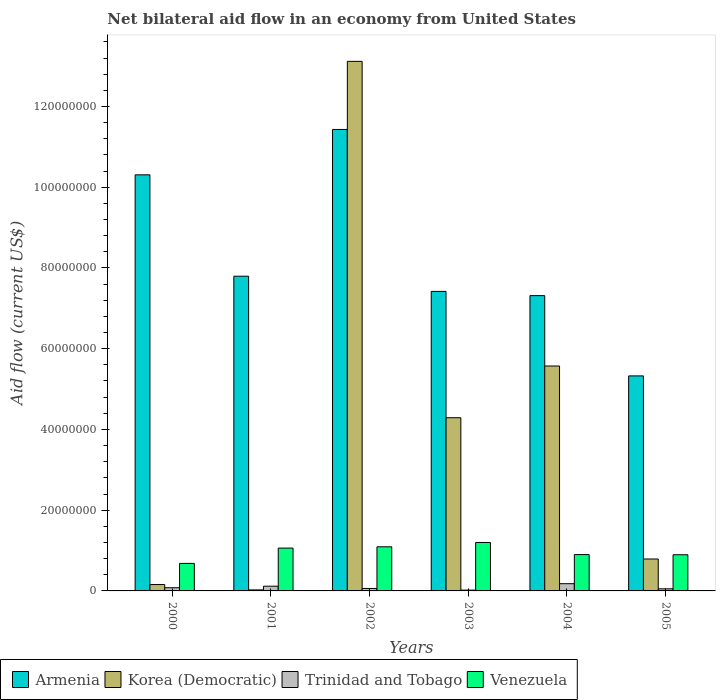Are the number of bars per tick equal to the number of legend labels?
Provide a short and direct response. Yes. Are the number of bars on each tick of the X-axis equal?
Make the answer very short. Yes. What is the label of the 6th group of bars from the left?
Ensure brevity in your answer.  2005. What is the net bilateral aid flow in Venezuela in 2001?
Offer a terse response. 1.06e+07. Across all years, what is the maximum net bilateral aid flow in Trinidad and Tobago?
Provide a short and direct response. 1.79e+06. Across all years, what is the minimum net bilateral aid flow in Trinidad and Tobago?
Offer a very short reply. 2.00e+05. What is the total net bilateral aid flow in Trinidad and Tobago in the graph?
Make the answer very short. 5.08e+06. What is the difference between the net bilateral aid flow in Venezuela in 2002 and that in 2003?
Give a very brief answer. -1.07e+06. What is the difference between the net bilateral aid flow in Venezuela in 2000 and the net bilateral aid flow in Trinidad and Tobago in 2005?
Make the answer very short. 6.30e+06. What is the average net bilateral aid flow in Korea (Democratic) per year?
Give a very brief answer. 3.99e+07. In the year 2000, what is the difference between the net bilateral aid flow in Armenia and net bilateral aid flow in Trinidad and Tobago?
Your answer should be compact. 1.02e+08. What is the ratio of the net bilateral aid flow in Venezuela in 2001 to that in 2004?
Provide a short and direct response. 1.18. What is the difference between the highest and the second highest net bilateral aid flow in Armenia?
Give a very brief answer. 1.12e+07. What is the difference between the highest and the lowest net bilateral aid flow in Venezuela?
Your answer should be very brief. 5.18e+06. Is it the case that in every year, the sum of the net bilateral aid flow in Armenia and net bilateral aid flow in Venezuela is greater than the sum of net bilateral aid flow in Korea (Democratic) and net bilateral aid flow in Trinidad and Tobago?
Your answer should be compact. Yes. What does the 1st bar from the left in 2002 represents?
Keep it short and to the point. Armenia. What does the 3rd bar from the right in 2002 represents?
Your response must be concise. Korea (Democratic). Is it the case that in every year, the sum of the net bilateral aid flow in Venezuela and net bilateral aid flow in Korea (Democratic) is greater than the net bilateral aid flow in Armenia?
Offer a terse response. No. How many bars are there?
Your answer should be very brief. 24. Are all the bars in the graph horizontal?
Keep it short and to the point. No. How many years are there in the graph?
Offer a very short reply. 6. Are the values on the major ticks of Y-axis written in scientific E-notation?
Your answer should be very brief. No. Does the graph contain grids?
Ensure brevity in your answer.  No. How many legend labels are there?
Provide a succinct answer. 4. What is the title of the graph?
Make the answer very short. Net bilateral aid flow in an economy from United States. Does "Rwanda" appear as one of the legend labels in the graph?
Give a very brief answer. No. What is the Aid flow (current US$) of Armenia in 2000?
Your response must be concise. 1.03e+08. What is the Aid flow (current US$) of Korea (Democratic) in 2000?
Ensure brevity in your answer.  1.58e+06. What is the Aid flow (current US$) of Trinidad and Tobago in 2000?
Keep it short and to the point. 7.90e+05. What is the Aid flow (current US$) in Venezuela in 2000?
Provide a short and direct response. 6.82e+06. What is the Aid flow (current US$) in Armenia in 2001?
Offer a very short reply. 7.80e+07. What is the Aid flow (current US$) of Korea (Democratic) in 2001?
Provide a short and direct response. 2.50e+05. What is the Aid flow (current US$) of Trinidad and Tobago in 2001?
Your answer should be very brief. 1.17e+06. What is the Aid flow (current US$) of Venezuela in 2001?
Your answer should be very brief. 1.06e+07. What is the Aid flow (current US$) in Armenia in 2002?
Provide a succinct answer. 1.14e+08. What is the Aid flow (current US$) in Korea (Democratic) in 2002?
Offer a very short reply. 1.31e+08. What is the Aid flow (current US$) in Trinidad and Tobago in 2002?
Provide a short and direct response. 6.10e+05. What is the Aid flow (current US$) of Venezuela in 2002?
Offer a terse response. 1.09e+07. What is the Aid flow (current US$) in Armenia in 2003?
Offer a very short reply. 7.42e+07. What is the Aid flow (current US$) of Korea (Democratic) in 2003?
Your response must be concise. 4.29e+07. What is the Aid flow (current US$) of Trinidad and Tobago in 2003?
Your answer should be compact. 2.00e+05. What is the Aid flow (current US$) of Venezuela in 2003?
Provide a short and direct response. 1.20e+07. What is the Aid flow (current US$) of Armenia in 2004?
Offer a very short reply. 7.31e+07. What is the Aid flow (current US$) of Korea (Democratic) in 2004?
Keep it short and to the point. 5.57e+07. What is the Aid flow (current US$) in Trinidad and Tobago in 2004?
Make the answer very short. 1.79e+06. What is the Aid flow (current US$) of Venezuela in 2004?
Ensure brevity in your answer.  9.00e+06. What is the Aid flow (current US$) of Armenia in 2005?
Provide a succinct answer. 5.33e+07. What is the Aid flow (current US$) of Korea (Democratic) in 2005?
Offer a very short reply. 7.91e+06. What is the Aid flow (current US$) of Trinidad and Tobago in 2005?
Provide a short and direct response. 5.20e+05. What is the Aid flow (current US$) in Venezuela in 2005?
Give a very brief answer. 8.96e+06. Across all years, what is the maximum Aid flow (current US$) of Armenia?
Give a very brief answer. 1.14e+08. Across all years, what is the maximum Aid flow (current US$) in Korea (Democratic)?
Offer a terse response. 1.31e+08. Across all years, what is the maximum Aid flow (current US$) in Trinidad and Tobago?
Offer a very short reply. 1.79e+06. Across all years, what is the maximum Aid flow (current US$) in Venezuela?
Offer a terse response. 1.20e+07. Across all years, what is the minimum Aid flow (current US$) in Armenia?
Provide a short and direct response. 5.33e+07. Across all years, what is the minimum Aid flow (current US$) in Korea (Democratic)?
Your answer should be very brief. 2.50e+05. Across all years, what is the minimum Aid flow (current US$) of Venezuela?
Your answer should be very brief. 6.82e+06. What is the total Aid flow (current US$) of Armenia in the graph?
Provide a succinct answer. 4.96e+08. What is the total Aid flow (current US$) in Korea (Democratic) in the graph?
Offer a terse response. 2.40e+08. What is the total Aid flow (current US$) in Trinidad and Tobago in the graph?
Your answer should be very brief. 5.08e+06. What is the total Aid flow (current US$) of Venezuela in the graph?
Keep it short and to the point. 5.83e+07. What is the difference between the Aid flow (current US$) in Armenia in 2000 and that in 2001?
Give a very brief answer. 2.51e+07. What is the difference between the Aid flow (current US$) in Korea (Democratic) in 2000 and that in 2001?
Your response must be concise. 1.33e+06. What is the difference between the Aid flow (current US$) in Trinidad and Tobago in 2000 and that in 2001?
Offer a very short reply. -3.80e+05. What is the difference between the Aid flow (current US$) of Venezuela in 2000 and that in 2001?
Give a very brief answer. -3.79e+06. What is the difference between the Aid flow (current US$) in Armenia in 2000 and that in 2002?
Make the answer very short. -1.12e+07. What is the difference between the Aid flow (current US$) of Korea (Democratic) in 2000 and that in 2002?
Your response must be concise. -1.30e+08. What is the difference between the Aid flow (current US$) in Trinidad and Tobago in 2000 and that in 2002?
Provide a succinct answer. 1.80e+05. What is the difference between the Aid flow (current US$) in Venezuela in 2000 and that in 2002?
Offer a terse response. -4.11e+06. What is the difference between the Aid flow (current US$) of Armenia in 2000 and that in 2003?
Your answer should be compact. 2.89e+07. What is the difference between the Aid flow (current US$) in Korea (Democratic) in 2000 and that in 2003?
Provide a succinct answer. -4.13e+07. What is the difference between the Aid flow (current US$) in Trinidad and Tobago in 2000 and that in 2003?
Your answer should be compact. 5.90e+05. What is the difference between the Aid flow (current US$) in Venezuela in 2000 and that in 2003?
Keep it short and to the point. -5.18e+06. What is the difference between the Aid flow (current US$) in Armenia in 2000 and that in 2004?
Keep it short and to the point. 2.99e+07. What is the difference between the Aid flow (current US$) in Korea (Democratic) in 2000 and that in 2004?
Offer a terse response. -5.41e+07. What is the difference between the Aid flow (current US$) in Trinidad and Tobago in 2000 and that in 2004?
Offer a very short reply. -1.00e+06. What is the difference between the Aid flow (current US$) of Venezuela in 2000 and that in 2004?
Your response must be concise. -2.18e+06. What is the difference between the Aid flow (current US$) in Armenia in 2000 and that in 2005?
Give a very brief answer. 4.98e+07. What is the difference between the Aid flow (current US$) in Korea (Democratic) in 2000 and that in 2005?
Provide a succinct answer. -6.33e+06. What is the difference between the Aid flow (current US$) in Trinidad and Tobago in 2000 and that in 2005?
Your response must be concise. 2.70e+05. What is the difference between the Aid flow (current US$) in Venezuela in 2000 and that in 2005?
Provide a short and direct response. -2.14e+06. What is the difference between the Aid flow (current US$) in Armenia in 2001 and that in 2002?
Your response must be concise. -3.64e+07. What is the difference between the Aid flow (current US$) of Korea (Democratic) in 2001 and that in 2002?
Offer a very short reply. -1.31e+08. What is the difference between the Aid flow (current US$) in Trinidad and Tobago in 2001 and that in 2002?
Your response must be concise. 5.60e+05. What is the difference between the Aid flow (current US$) in Venezuela in 2001 and that in 2002?
Keep it short and to the point. -3.20e+05. What is the difference between the Aid flow (current US$) in Armenia in 2001 and that in 2003?
Provide a short and direct response. 3.76e+06. What is the difference between the Aid flow (current US$) in Korea (Democratic) in 2001 and that in 2003?
Make the answer very short. -4.26e+07. What is the difference between the Aid flow (current US$) of Trinidad and Tobago in 2001 and that in 2003?
Offer a very short reply. 9.70e+05. What is the difference between the Aid flow (current US$) of Venezuela in 2001 and that in 2003?
Give a very brief answer. -1.39e+06. What is the difference between the Aid flow (current US$) of Armenia in 2001 and that in 2004?
Provide a short and direct response. 4.81e+06. What is the difference between the Aid flow (current US$) of Korea (Democratic) in 2001 and that in 2004?
Offer a terse response. -5.55e+07. What is the difference between the Aid flow (current US$) of Trinidad and Tobago in 2001 and that in 2004?
Provide a succinct answer. -6.20e+05. What is the difference between the Aid flow (current US$) of Venezuela in 2001 and that in 2004?
Keep it short and to the point. 1.61e+06. What is the difference between the Aid flow (current US$) of Armenia in 2001 and that in 2005?
Offer a terse response. 2.47e+07. What is the difference between the Aid flow (current US$) of Korea (Democratic) in 2001 and that in 2005?
Offer a very short reply. -7.66e+06. What is the difference between the Aid flow (current US$) in Trinidad and Tobago in 2001 and that in 2005?
Ensure brevity in your answer.  6.50e+05. What is the difference between the Aid flow (current US$) of Venezuela in 2001 and that in 2005?
Give a very brief answer. 1.65e+06. What is the difference between the Aid flow (current US$) of Armenia in 2002 and that in 2003?
Ensure brevity in your answer.  4.01e+07. What is the difference between the Aid flow (current US$) in Korea (Democratic) in 2002 and that in 2003?
Your answer should be very brief. 8.83e+07. What is the difference between the Aid flow (current US$) in Trinidad and Tobago in 2002 and that in 2003?
Provide a short and direct response. 4.10e+05. What is the difference between the Aid flow (current US$) in Venezuela in 2002 and that in 2003?
Keep it short and to the point. -1.07e+06. What is the difference between the Aid flow (current US$) of Armenia in 2002 and that in 2004?
Ensure brevity in your answer.  4.12e+07. What is the difference between the Aid flow (current US$) in Korea (Democratic) in 2002 and that in 2004?
Keep it short and to the point. 7.55e+07. What is the difference between the Aid flow (current US$) in Trinidad and Tobago in 2002 and that in 2004?
Keep it short and to the point. -1.18e+06. What is the difference between the Aid flow (current US$) of Venezuela in 2002 and that in 2004?
Give a very brief answer. 1.93e+06. What is the difference between the Aid flow (current US$) in Armenia in 2002 and that in 2005?
Make the answer very short. 6.10e+07. What is the difference between the Aid flow (current US$) of Korea (Democratic) in 2002 and that in 2005?
Your answer should be compact. 1.23e+08. What is the difference between the Aid flow (current US$) in Venezuela in 2002 and that in 2005?
Provide a succinct answer. 1.97e+06. What is the difference between the Aid flow (current US$) of Armenia in 2003 and that in 2004?
Your answer should be compact. 1.05e+06. What is the difference between the Aid flow (current US$) of Korea (Democratic) in 2003 and that in 2004?
Keep it short and to the point. -1.28e+07. What is the difference between the Aid flow (current US$) of Trinidad and Tobago in 2003 and that in 2004?
Provide a short and direct response. -1.59e+06. What is the difference between the Aid flow (current US$) of Venezuela in 2003 and that in 2004?
Keep it short and to the point. 3.00e+06. What is the difference between the Aid flow (current US$) of Armenia in 2003 and that in 2005?
Your response must be concise. 2.09e+07. What is the difference between the Aid flow (current US$) of Korea (Democratic) in 2003 and that in 2005?
Your answer should be very brief. 3.50e+07. What is the difference between the Aid flow (current US$) of Trinidad and Tobago in 2003 and that in 2005?
Keep it short and to the point. -3.20e+05. What is the difference between the Aid flow (current US$) of Venezuela in 2003 and that in 2005?
Your answer should be compact. 3.04e+06. What is the difference between the Aid flow (current US$) of Armenia in 2004 and that in 2005?
Provide a succinct answer. 1.99e+07. What is the difference between the Aid flow (current US$) in Korea (Democratic) in 2004 and that in 2005?
Offer a very short reply. 4.78e+07. What is the difference between the Aid flow (current US$) in Trinidad and Tobago in 2004 and that in 2005?
Keep it short and to the point. 1.27e+06. What is the difference between the Aid flow (current US$) in Armenia in 2000 and the Aid flow (current US$) in Korea (Democratic) in 2001?
Make the answer very short. 1.03e+08. What is the difference between the Aid flow (current US$) in Armenia in 2000 and the Aid flow (current US$) in Trinidad and Tobago in 2001?
Offer a very short reply. 1.02e+08. What is the difference between the Aid flow (current US$) in Armenia in 2000 and the Aid flow (current US$) in Venezuela in 2001?
Your response must be concise. 9.24e+07. What is the difference between the Aid flow (current US$) of Korea (Democratic) in 2000 and the Aid flow (current US$) of Venezuela in 2001?
Give a very brief answer. -9.03e+06. What is the difference between the Aid flow (current US$) in Trinidad and Tobago in 2000 and the Aid flow (current US$) in Venezuela in 2001?
Offer a very short reply. -9.82e+06. What is the difference between the Aid flow (current US$) of Armenia in 2000 and the Aid flow (current US$) of Korea (Democratic) in 2002?
Keep it short and to the point. -2.81e+07. What is the difference between the Aid flow (current US$) in Armenia in 2000 and the Aid flow (current US$) in Trinidad and Tobago in 2002?
Offer a very short reply. 1.02e+08. What is the difference between the Aid flow (current US$) in Armenia in 2000 and the Aid flow (current US$) in Venezuela in 2002?
Your response must be concise. 9.21e+07. What is the difference between the Aid flow (current US$) of Korea (Democratic) in 2000 and the Aid flow (current US$) of Trinidad and Tobago in 2002?
Give a very brief answer. 9.70e+05. What is the difference between the Aid flow (current US$) of Korea (Democratic) in 2000 and the Aid flow (current US$) of Venezuela in 2002?
Provide a short and direct response. -9.35e+06. What is the difference between the Aid flow (current US$) of Trinidad and Tobago in 2000 and the Aid flow (current US$) of Venezuela in 2002?
Provide a succinct answer. -1.01e+07. What is the difference between the Aid flow (current US$) in Armenia in 2000 and the Aid flow (current US$) in Korea (Democratic) in 2003?
Your answer should be very brief. 6.02e+07. What is the difference between the Aid flow (current US$) in Armenia in 2000 and the Aid flow (current US$) in Trinidad and Tobago in 2003?
Your answer should be very brief. 1.03e+08. What is the difference between the Aid flow (current US$) in Armenia in 2000 and the Aid flow (current US$) in Venezuela in 2003?
Provide a short and direct response. 9.11e+07. What is the difference between the Aid flow (current US$) of Korea (Democratic) in 2000 and the Aid flow (current US$) of Trinidad and Tobago in 2003?
Ensure brevity in your answer.  1.38e+06. What is the difference between the Aid flow (current US$) of Korea (Democratic) in 2000 and the Aid flow (current US$) of Venezuela in 2003?
Give a very brief answer. -1.04e+07. What is the difference between the Aid flow (current US$) of Trinidad and Tobago in 2000 and the Aid flow (current US$) of Venezuela in 2003?
Keep it short and to the point. -1.12e+07. What is the difference between the Aid flow (current US$) of Armenia in 2000 and the Aid flow (current US$) of Korea (Democratic) in 2004?
Provide a short and direct response. 4.74e+07. What is the difference between the Aid flow (current US$) of Armenia in 2000 and the Aid flow (current US$) of Trinidad and Tobago in 2004?
Make the answer very short. 1.01e+08. What is the difference between the Aid flow (current US$) in Armenia in 2000 and the Aid flow (current US$) in Venezuela in 2004?
Give a very brief answer. 9.41e+07. What is the difference between the Aid flow (current US$) in Korea (Democratic) in 2000 and the Aid flow (current US$) in Trinidad and Tobago in 2004?
Your answer should be very brief. -2.10e+05. What is the difference between the Aid flow (current US$) of Korea (Democratic) in 2000 and the Aid flow (current US$) of Venezuela in 2004?
Your response must be concise. -7.42e+06. What is the difference between the Aid flow (current US$) in Trinidad and Tobago in 2000 and the Aid flow (current US$) in Venezuela in 2004?
Provide a succinct answer. -8.21e+06. What is the difference between the Aid flow (current US$) in Armenia in 2000 and the Aid flow (current US$) in Korea (Democratic) in 2005?
Provide a short and direct response. 9.52e+07. What is the difference between the Aid flow (current US$) in Armenia in 2000 and the Aid flow (current US$) in Trinidad and Tobago in 2005?
Provide a succinct answer. 1.03e+08. What is the difference between the Aid flow (current US$) in Armenia in 2000 and the Aid flow (current US$) in Venezuela in 2005?
Offer a terse response. 9.41e+07. What is the difference between the Aid flow (current US$) in Korea (Democratic) in 2000 and the Aid flow (current US$) in Trinidad and Tobago in 2005?
Offer a very short reply. 1.06e+06. What is the difference between the Aid flow (current US$) in Korea (Democratic) in 2000 and the Aid flow (current US$) in Venezuela in 2005?
Provide a succinct answer. -7.38e+06. What is the difference between the Aid flow (current US$) in Trinidad and Tobago in 2000 and the Aid flow (current US$) in Venezuela in 2005?
Ensure brevity in your answer.  -8.17e+06. What is the difference between the Aid flow (current US$) in Armenia in 2001 and the Aid flow (current US$) in Korea (Democratic) in 2002?
Make the answer very short. -5.32e+07. What is the difference between the Aid flow (current US$) in Armenia in 2001 and the Aid flow (current US$) in Trinidad and Tobago in 2002?
Ensure brevity in your answer.  7.73e+07. What is the difference between the Aid flow (current US$) of Armenia in 2001 and the Aid flow (current US$) of Venezuela in 2002?
Your answer should be very brief. 6.70e+07. What is the difference between the Aid flow (current US$) of Korea (Democratic) in 2001 and the Aid flow (current US$) of Trinidad and Tobago in 2002?
Offer a terse response. -3.60e+05. What is the difference between the Aid flow (current US$) of Korea (Democratic) in 2001 and the Aid flow (current US$) of Venezuela in 2002?
Offer a very short reply. -1.07e+07. What is the difference between the Aid flow (current US$) of Trinidad and Tobago in 2001 and the Aid flow (current US$) of Venezuela in 2002?
Give a very brief answer. -9.76e+06. What is the difference between the Aid flow (current US$) of Armenia in 2001 and the Aid flow (current US$) of Korea (Democratic) in 2003?
Provide a succinct answer. 3.50e+07. What is the difference between the Aid flow (current US$) in Armenia in 2001 and the Aid flow (current US$) in Trinidad and Tobago in 2003?
Give a very brief answer. 7.78e+07. What is the difference between the Aid flow (current US$) in Armenia in 2001 and the Aid flow (current US$) in Venezuela in 2003?
Your answer should be very brief. 6.60e+07. What is the difference between the Aid flow (current US$) of Korea (Democratic) in 2001 and the Aid flow (current US$) of Venezuela in 2003?
Your answer should be compact. -1.18e+07. What is the difference between the Aid flow (current US$) in Trinidad and Tobago in 2001 and the Aid flow (current US$) in Venezuela in 2003?
Offer a terse response. -1.08e+07. What is the difference between the Aid flow (current US$) in Armenia in 2001 and the Aid flow (current US$) in Korea (Democratic) in 2004?
Offer a terse response. 2.22e+07. What is the difference between the Aid flow (current US$) of Armenia in 2001 and the Aid flow (current US$) of Trinidad and Tobago in 2004?
Give a very brief answer. 7.62e+07. What is the difference between the Aid flow (current US$) in Armenia in 2001 and the Aid flow (current US$) in Venezuela in 2004?
Keep it short and to the point. 6.90e+07. What is the difference between the Aid flow (current US$) of Korea (Democratic) in 2001 and the Aid flow (current US$) of Trinidad and Tobago in 2004?
Provide a succinct answer. -1.54e+06. What is the difference between the Aid flow (current US$) of Korea (Democratic) in 2001 and the Aid flow (current US$) of Venezuela in 2004?
Keep it short and to the point. -8.75e+06. What is the difference between the Aid flow (current US$) of Trinidad and Tobago in 2001 and the Aid flow (current US$) of Venezuela in 2004?
Offer a terse response. -7.83e+06. What is the difference between the Aid flow (current US$) of Armenia in 2001 and the Aid flow (current US$) of Korea (Democratic) in 2005?
Offer a very short reply. 7.00e+07. What is the difference between the Aid flow (current US$) of Armenia in 2001 and the Aid flow (current US$) of Trinidad and Tobago in 2005?
Offer a terse response. 7.74e+07. What is the difference between the Aid flow (current US$) in Armenia in 2001 and the Aid flow (current US$) in Venezuela in 2005?
Ensure brevity in your answer.  6.90e+07. What is the difference between the Aid flow (current US$) in Korea (Democratic) in 2001 and the Aid flow (current US$) in Trinidad and Tobago in 2005?
Your answer should be very brief. -2.70e+05. What is the difference between the Aid flow (current US$) in Korea (Democratic) in 2001 and the Aid flow (current US$) in Venezuela in 2005?
Your answer should be very brief. -8.71e+06. What is the difference between the Aid flow (current US$) in Trinidad and Tobago in 2001 and the Aid flow (current US$) in Venezuela in 2005?
Provide a short and direct response. -7.79e+06. What is the difference between the Aid flow (current US$) in Armenia in 2002 and the Aid flow (current US$) in Korea (Democratic) in 2003?
Your answer should be compact. 7.14e+07. What is the difference between the Aid flow (current US$) in Armenia in 2002 and the Aid flow (current US$) in Trinidad and Tobago in 2003?
Offer a very short reply. 1.14e+08. What is the difference between the Aid flow (current US$) in Armenia in 2002 and the Aid flow (current US$) in Venezuela in 2003?
Offer a terse response. 1.02e+08. What is the difference between the Aid flow (current US$) in Korea (Democratic) in 2002 and the Aid flow (current US$) in Trinidad and Tobago in 2003?
Offer a very short reply. 1.31e+08. What is the difference between the Aid flow (current US$) of Korea (Democratic) in 2002 and the Aid flow (current US$) of Venezuela in 2003?
Make the answer very short. 1.19e+08. What is the difference between the Aid flow (current US$) of Trinidad and Tobago in 2002 and the Aid flow (current US$) of Venezuela in 2003?
Give a very brief answer. -1.14e+07. What is the difference between the Aid flow (current US$) in Armenia in 2002 and the Aid flow (current US$) in Korea (Democratic) in 2004?
Offer a terse response. 5.86e+07. What is the difference between the Aid flow (current US$) of Armenia in 2002 and the Aid flow (current US$) of Trinidad and Tobago in 2004?
Your answer should be compact. 1.13e+08. What is the difference between the Aid flow (current US$) in Armenia in 2002 and the Aid flow (current US$) in Venezuela in 2004?
Your answer should be very brief. 1.05e+08. What is the difference between the Aid flow (current US$) in Korea (Democratic) in 2002 and the Aid flow (current US$) in Trinidad and Tobago in 2004?
Ensure brevity in your answer.  1.29e+08. What is the difference between the Aid flow (current US$) of Korea (Democratic) in 2002 and the Aid flow (current US$) of Venezuela in 2004?
Provide a short and direct response. 1.22e+08. What is the difference between the Aid flow (current US$) in Trinidad and Tobago in 2002 and the Aid flow (current US$) in Venezuela in 2004?
Offer a terse response. -8.39e+06. What is the difference between the Aid flow (current US$) in Armenia in 2002 and the Aid flow (current US$) in Korea (Democratic) in 2005?
Provide a short and direct response. 1.06e+08. What is the difference between the Aid flow (current US$) in Armenia in 2002 and the Aid flow (current US$) in Trinidad and Tobago in 2005?
Give a very brief answer. 1.14e+08. What is the difference between the Aid flow (current US$) of Armenia in 2002 and the Aid flow (current US$) of Venezuela in 2005?
Keep it short and to the point. 1.05e+08. What is the difference between the Aid flow (current US$) of Korea (Democratic) in 2002 and the Aid flow (current US$) of Trinidad and Tobago in 2005?
Offer a very short reply. 1.31e+08. What is the difference between the Aid flow (current US$) in Korea (Democratic) in 2002 and the Aid flow (current US$) in Venezuela in 2005?
Provide a short and direct response. 1.22e+08. What is the difference between the Aid flow (current US$) in Trinidad and Tobago in 2002 and the Aid flow (current US$) in Venezuela in 2005?
Your response must be concise. -8.35e+06. What is the difference between the Aid flow (current US$) in Armenia in 2003 and the Aid flow (current US$) in Korea (Democratic) in 2004?
Keep it short and to the point. 1.85e+07. What is the difference between the Aid flow (current US$) in Armenia in 2003 and the Aid flow (current US$) in Trinidad and Tobago in 2004?
Your response must be concise. 7.24e+07. What is the difference between the Aid flow (current US$) in Armenia in 2003 and the Aid flow (current US$) in Venezuela in 2004?
Offer a very short reply. 6.52e+07. What is the difference between the Aid flow (current US$) of Korea (Democratic) in 2003 and the Aid flow (current US$) of Trinidad and Tobago in 2004?
Offer a terse response. 4.11e+07. What is the difference between the Aid flow (current US$) in Korea (Democratic) in 2003 and the Aid flow (current US$) in Venezuela in 2004?
Provide a short and direct response. 3.39e+07. What is the difference between the Aid flow (current US$) in Trinidad and Tobago in 2003 and the Aid flow (current US$) in Venezuela in 2004?
Offer a very short reply. -8.80e+06. What is the difference between the Aid flow (current US$) in Armenia in 2003 and the Aid flow (current US$) in Korea (Democratic) in 2005?
Offer a terse response. 6.63e+07. What is the difference between the Aid flow (current US$) of Armenia in 2003 and the Aid flow (current US$) of Trinidad and Tobago in 2005?
Provide a short and direct response. 7.37e+07. What is the difference between the Aid flow (current US$) of Armenia in 2003 and the Aid flow (current US$) of Venezuela in 2005?
Offer a very short reply. 6.52e+07. What is the difference between the Aid flow (current US$) of Korea (Democratic) in 2003 and the Aid flow (current US$) of Trinidad and Tobago in 2005?
Provide a succinct answer. 4.24e+07. What is the difference between the Aid flow (current US$) in Korea (Democratic) in 2003 and the Aid flow (current US$) in Venezuela in 2005?
Ensure brevity in your answer.  3.39e+07. What is the difference between the Aid flow (current US$) in Trinidad and Tobago in 2003 and the Aid flow (current US$) in Venezuela in 2005?
Make the answer very short. -8.76e+06. What is the difference between the Aid flow (current US$) in Armenia in 2004 and the Aid flow (current US$) in Korea (Democratic) in 2005?
Your response must be concise. 6.52e+07. What is the difference between the Aid flow (current US$) in Armenia in 2004 and the Aid flow (current US$) in Trinidad and Tobago in 2005?
Provide a short and direct response. 7.26e+07. What is the difference between the Aid flow (current US$) of Armenia in 2004 and the Aid flow (current US$) of Venezuela in 2005?
Offer a terse response. 6.42e+07. What is the difference between the Aid flow (current US$) of Korea (Democratic) in 2004 and the Aid flow (current US$) of Trinidad and Tobago in 2005?
Keep it short and to the point. 5.52e+07. What is the difference between the Aid flow (current US$) in Korea (Democratic) in 2004 and the Aid flow (current US$) in Venezuela in 2005?
Provide a succinct answer. 4.68e+07. What is the difference between the Aid flow (current US$) of Trinidad and Tobago in 2004 and the Aid flow (current US$) of Venezuela in 2005?
Provide a succinct answer. -7.17e+06. What is the average Aid flow (current US$) in Armenia per year?
Give a very brief answer. 8.26e+07. What is the average Aid flow (current US$) in Korea (Democratic) per year?
Keep it short and to the point. 3.99e+07. What is the average Aid flow (current US$) in Trinidad and Tobago per year?
Your response must be concise. 8.47e+05. What is the average Aid flow (current US$) of Venezuela per year?
Make the answer very short. 9.72e+06. In the year 2000, what is the difference between the Aid flow (current US$) in Armenia and Aid flow (current US$) in Korea (Democratic)?
Give a very brief answer. 1.01e+08. In the year 2000, what is the difference between the Aid flow (current US$) in Armenia and Aid flow (current US$) in Trinidad and Tobago?
Keep it short and to the point. 1.02e+08. In the year 2000, what is the difference between the Aid flow (current US$) in Armenia and Aid flow (current US$) in Venezuela?
Your answer should be very brief. 9.62e+07. In the year 2000, what is the difference between the Aid flow (current US$) in Korea (Democratic) and Aid flow (current US$) in Trinidad and Tobago?
Your answer should be compact. 7.90e+05. In the year 2000, what is the difference between the Aid flow (current US$) of Korea (Democratic) and Aid flow (current US$) of Venezuela?
Your answer should be compact. -5.24e+06. In the year 2000, what is the difference between the Aid flow (current US$) of Trinidad and Tobago and Aid flow (current US$) of Venezuela?
Keep it short and to the point. -6.03e+06. In the year 2001, what is the difference between the Aid flow (current US$) of Armenia and Aid flow (current US$) of Korea (Democratic)?
Provide a succinct answer. 7.77e+07. In the year 2001, what is the difference between the Aid flow (current US$) in Armenia and Aid flow (current US$) in Trinidad and Tobago?
Offer a very short reply. 7.68e+07. In the year 2001, what is the difference between the Aid flow (current US$) in Armenia and Aid flow (current US$) in Venezuela?
Your response must be concise. 6.73e+07. In the year 2001, what is the difference between the Aid flow (current US$) of Korea (Democratic) and Aid flow (current US$) of Trinidad and Tobago?
Give a very brief answer. -9.20e+05. In the year 2001, what is the difference between the Aid flow (current US$) of Korea (Democratic) and Aid flow (current US$) of Venezuela?
Your response must be concise. -1.04e+07. In the year 2001, what is the difference between the Aid flow (current US$) in Trinidad and Tobago and Aid flow (current US$) in Venezuela?
Make the answer very short. -9.44e+06. In the year 2002, what is the difference between the Aid flow (current US$) in Armenia and Aid flow (current US$) in Korea (Democratic)?
Your response must be concise. -1.69e+07. In the year 2002, what is the difference between the Aid flow (current US$) of Armenia and Aid flow (current US$) of Trinidad and Tobago?
Provide a succinct answer. 1.14e+08. In the year 2002, what is the difference between the Aid flow (current US$) of Armenia and Aid flow (current US$) of Venezuela?
Make the answer very short. 1.03e+08. In the year 2002, what is the difference between the Aid flow (current US$) of Korea (Democratic) and Aid flow (current US$) of Trinidad and Tobago?
Offer a very short reply. 1.31e+08. In the year 2002, what is the difference between the Aid flow (current US$) in Korea (Democratic) and Aid flow (current US$) in Venezuela?
Keep it short and to the point. 1.20e+08. In the year 2002, what is the difference between the Aid flow (current US$) in Trinidad and Tobago and Aid flow (current US$) in Venezuela?
Your answer should be very brief. -1.03e+07. In the year 2003, what is the difference between the Aid flow (current US$) in Armenia and Aid flow (current US$) in Korea (Democratic)?
Offer a terse response. 3.13e+07. In the year 2003, what is the difference between the Aid flow (current US$) in Armenia and Aid flow (current US$) in Trinidad and Tobago?
Provide a short and direct response. 7.40e+07. In the year 2003, what is the difference between the Aid flow (current US$) of Armenia and Aid flow (current US$) of Venezuela?
Your answer should be compact. 6.22e+07. In the year 2003, what is the difference between the Aid flow (current US$) of Korea (Democratic) and Aid flow (current US$) of Trinidad and Tobago?
Offer a very short reply. 4.27e+07. In the year 2003, what is the difference between the Aid flow (current US$) in Korea (Democratic) and Aid flow (current US$) in Venezuela?
Give a very brief answer. 3.09e+07. In the year 2003, what is the difference between the Aid flow (current US$) in Trinidad and Tobago and Aid flow (current US$) in Venezuela?
Provide a short and direct response. -1.18e+07. In the year 2004, what is the difference between the Aid flow (current US$) in Armenia and Aid flow (current US$) in Korea (Democratic)?
Offer a terse response. 1.74e+07. In the year 2004, what is the difference between the Aid flow (current US$) of Armenia and Aid flow (current US$) of Trinidad and Tobago?
Your answer should be compact. 7.14e+07. In the year 2004, what is the difference between the Aid flow (current US$) of Armenia and Aid flow (current US$) of Venezuela?
Your answer should be very brief. 6.41e+07. In the year 2004, what is the difference between the Aid flow (current US$) in Korea (Democratic) and Aid flow (current US$) in Trinidad and Tobago?
Your response must be concise. 5.39e+07. In the year 2004, what is the difference between the Aid flow (current US$) in Korea (Democratic) and Aid flow (current US$) in Venezuela?
Provide a short and direct response. 4.67e+07. In the year 2004, what is the difference between the Aid flow (current US$) of Trinidad and Tobago and Aid flow (current US$) of Venezuela?
Offer a very short reply. -7.21e+06. In the year 2005, what is the difference between the Aid flow (current US$) of Armenia and Aid flow (current US$) of Korea (Democratic)?
Make the answer very short. 4.54e+07. In the year 2005, what is the difference between the Aid flow (current US$) in Armenia and Aid flow (current US$) in Trinidad and Tobago?
Your answer should be compact. 5.27e+07. In the year 2005, what is the difference between the Aid flow (current US$) of Armenia and Aid flow (current US$) of Venezuela?
Make the answer very short. 4.43e+07. In the year 2005, what is the difference between the Aid flow (current US$) of Korea (Democratic) and Aid flow (current US$) of Trinidad and Tobago?
Your response must be concise. 7.39e+06. In the year 2005, what is the difference between the Aid flow (current US$) in Korea (Democratic) and Aid flow (current US$) in Venezuela?
Give a very brief answer. -1.05e+06. In the year 2005, what is the difference between the Aid flow (current US$) of Trinidad and Tobago and Aid flow (current US$) of Venezuela?
Make the answer very short. -8.44e+06. What is the ratio of the Aid flow (current US$) of Armenia in 2000 to that in 2001?
Your answer should be compact. 1.32. What is the ratio of the Aid flow (current US$) in Korea (Democratic) in 2000 to that in 2001?
Keep it short and to the point. 6.32. What is the ratio of the Aid flow (current US$) of Trinidad and Tobago in 2000 to that in 2001?
Your response must be concise. 0.68. What is the ratio of the Aid flow (current US$) of Venezuela in 2000 to that in 2001?
Ensure brevity in your answer.  0.64. What is the ratio of the Aid flow (current US$) of Armenia in 2000 to that in 2002?
Your answer should be very brief. 0.9. What is the ratio of the Aid flow (current US$) in Korea (Democratic) in 2000 to that in 2002?
Give a very brief answer. 0.01. What is the ratio of the Aid flow (current US$) of Trinidad and Tobago in 2000 to that in 2002?
Make the answer very short. 1.3. What is the ratio of the Aid flow (current US$) of Venezuela in 2000 to that in 2002?
Ensure brevity in your answer.  0.62. What is the ratio of the Aid flow (current US$) in Armenia in 2000 to that in 2003?
Ensure brevity in your answer.  1.39. What is the ratio of the Aid flow (current US$) in Korea (Democratic) in 2000 to that in 2003?
Offer a terse response. 0.04. What is the ratio of the Aid flow (current US$) of Trinidad and Tobago in 2000 to that in 2003?
Ensure brevity in your answer.  3.95. What is the ratio of the Aid flow (current US$) in Venezuela in 2000 to that in 2003?
Keep it short and to the point. 0.57. What is the ratio of the Aid flow (current US$) of Armenia in 2000 to that in 2004?
Your response must be concise. 1.41. What is the ratio of the Aid flow (current US$) of Korea (Democratic) in 2000 to that in 2004?
Provide a short and direct response. 0.03. What is the ratio of the Aid flow (current US$) of Trinidad and Tobago in 2000 to that in 2004?
Offer a terse response. 0.44. What is the ratio of the Aid flow (current US$) of Venezuela in 2000 to that in 2004?
Keep it short and to the point. 0.76. What is the ratio of the Aid flow (current US$) of Armenia in 2000 to that in 2005?
Ensure brevity in your answer.  1.94. What is the ratio of the Aid flow (current US$) in Korea (Democratic) in 2000 to that in 2005?
Offer a terse response. 0.2. What is the ratio of the Aid flow (current US$) in Trinidad and Tobago in 2000 to that in 2005?
Make the answer very short. 1.52. What is the ratio of the Aid flow (current US$) in Venezuela in 2000 to that in 2005?
Provide a short and direct response. 0.76. What is the ratio of the Aid flow (current US$) of Armenia in 2001 to that in 2002?
Offer a very short reply. 0.68. What is the ratio of the Aid flow (current US$) of Korea (Democratic) in 2001 to that in 2002?
Your response must be concise. 0. What is the ratio of the Aid flow (current US$) in Trinidad and Tobago in 2001 to that in 2002?
Your response must be concise. 1.92. What is the ratio of the Aid flow (current US$) in Venezuela in 2001 to that in 2002?
Provide a short and direct response. 0.97. What is the ratio of the Aid flow (current US$) in Armenia in 2001 to that in 2003?
Give a very brief answer. 1.05. What is the ratio of the Aid flow (current US$) of Korea (Democratic) in 2001 to that in 2003?
Your response must be concise. 0.01. What is the ratio of the Aid flow (current US$) of Trinidad and Tobago in 2001 to that in 2003?
Your response must be concise. 5.85. What is the ratio of the Aid flow (current US$) of Venezuela in 2001 to that in 2003?
Provide a short and direct response. 0.88. What is the ratio of the Aid flow (current US$) in Armenia in 2001 to that in 2004?
Your answer should be very brief. 1.07. What is the ratio of the Aid flow (current US$) in Korea (Democratic) in 2001 to that in 2004?
Make the answer very short. 0. What is the ratio of the Aid flow (current US$) of Trinidad and Tobago in 2001 to that in 2004?
Ensure brevity in your answer.  0.65. What is the ratio of the Aid flow (current US$) of Venezuela in 2001 to that in 2004?
Your answer should be very brief. 1.18. What is the ratio of the Aid flow (current US$) in Armenia in 2001 to that in 2005?
Offer a very short reply. 1.46. What is the ratio of the Aid flow (current US$) in Korea (Democratic) in 2001 to that in 2005?
Your answer should be very brief. 0.03. What is the ratio of the Aid flow (current US$) in Trinidad and Tobago in 2001 to that in 2005?
Your response must be concise. 2.25. What is the ratio of the Aid flow (current US$) in Venezuela in 2001 to that in 2005?
Offer a terse response. 1.18. What is the ratio of the Aid flow (current US$) of Armenia in 2002 to that in 2003?
Provide a succinct answer. 1.54. What is the ratio of the Aid flow (current US$) in Korea (Democratic) in 2002 to that in 2003?
Make the answer very short. 3.06. What is the ratio of the Aid flow (current US$) in Trinidad and Tobago in 2002 to that in 2003?
Offer a terse response. 3.05. What is the ratio of the Aid flow (current US$) in Venezuela in 2002 to that in 2003?
Make the answer very short. 0.91. What is the ratio of the Aid flow (current US$) of Armenia in 2002 to that in 2004?
Make the answer very short. 1.56. What is the ratio of the Aid flow (current US$) in Korea (Democratic) in 2002 to that in 2004?
Offer a terse response. 2.35. What is the ratio of the Aid flow (current US$) in Trinidad and Tobago in 2002 to that in 2004?
Your answer should be very brief. 0.34. What is the ratio of the Aid flow (current US$) of Venezuela in 2002 to that in 2004?
Offer a very short reply. 1.21. What is the ratio of the Aid flow (current US$) in Armenia in 2002 to that in 2005?
Offer a very short reply. 2.15. What is the ratio of the Aid flow (current US$) of Korea (Democratic) in 2002 to that in 2005?
Offer a very short reply. 16.58. What is the ratio of the Aid flow (current US$) in Trinidad and Tobago in 2002 to that in 2005?
Make the answer very short. 1.17. What is the ratio of the Aid flow (current US$) of Venezuela in 2002 to that in 2005?
Offer a very short reply. 1.22. What is the ratio of the Aid flow (current US$) in Armenia in 2003 to that in 2004?
Offer a very short reply. 1.01. What is the ratio of the Aid flow (current US$) in Korea (Democratic) in 2003 to that in 2004?
Make the answer very short. 0.77. What is the ratio of the Aid flow (current US$) of Trinidad and Tobago in 2003 to that in 2004?
Your response must be concise. 0.11. What is the ratio of the Aid flow (current US$) of Venezuela in 2003 to that in 2004?
Make the answer very short. 1.33. What is the ratio of the Aid flow (current US$) in Armenia in 2003 to that in 2005?
Ensure brevity in your answer.  1.39. What is the ratio of the Aid flow (current US$) of Korea (Democratic) in 2003 to that in 2005?
Keep it short and to the point. 5.42. What is the ratio of the Aid flow (current US$) in Trinidad and Tobago in 2003 to that in 2005?
Keep it short and to the point. 0.38. What is the ratio of the Aid flow (current US$) of Venezuela in 2003 to that in 2005?
Make the answer very short. 1.34. What is the ratio of the Aid flow (current US$) in Armenia in 2004 to that in 2005?
Your answer should be very brief. 1.37. What is the ratio of the Aid flow (current US$) in Korea (Democratic) in 2004 to that in 2005?
Offer a terse response. 7.04. What is the ratio of the Aid flow (current US$) in Trinidad and Tobago in 2004 to that in 2005?
Your answer should be very brief. 3.44. What is the ratio of the Aid flow (current US$) of Venezuela in 2004 to that in 2005?
Your answer should be compact. 1. What is the difference between the highest and the second highest Aid flow (current US$) in Armenia?
Offer a terse response. 1.12e+07. What is the difference between the highest and the second highest Aid flow (current US$) in Korea (Democratic)?
Give a very brief answer. 7.55e+07. What is the difference between the highest and the second highest Aid flow (current US$) of Trinidad and Tobago?
Offer a terse response. 6.20e+05. What is the difference between the highest and the second highest Aid flow (current US$) in Venezuela?
Your response must be concise. 1.07e+06. What is the difference between the highest and the lowest Aid flow (current US$) in Armenia?
Provide a succinct answer. 6.10e+07. What is the difference between the highest and the lowest Aid flow (current US$) in Korea (Democratic)?
Provide a succinct answer. 1.31e+08. What is the difference between the highest and the lowest Aid flow (current US$) in Trinidad and Tobago?
Make the answer very short. 1.59e+06. What is the difference between the highest and the lowest Aid flow (current US$) in Venezuela?
Your answer should be compact. 5.18e+06. 